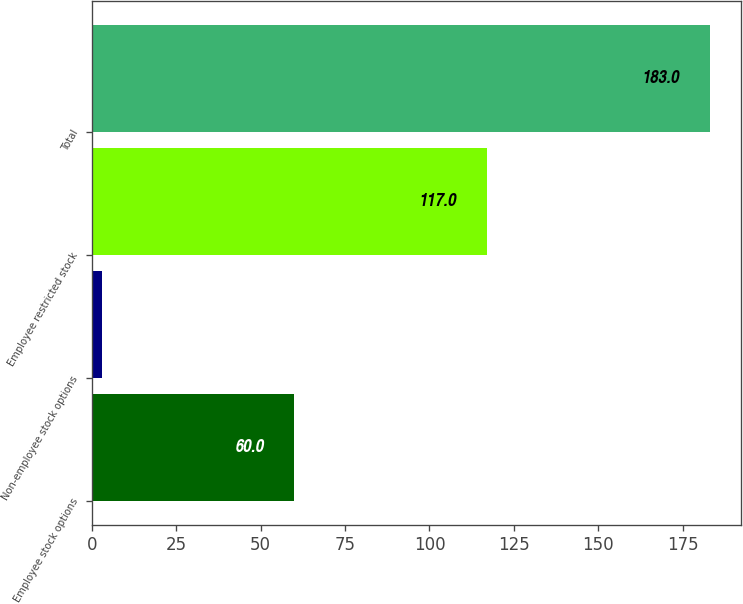Convert chart to OTSL. <chart><loc_0><loc_0><loc_500><loc_500><bar_chart><fcel>Employee stock options<fcel>Non-employee stock options<fcel>Employee restricted stock<fcel>Total<nl><fcel>60<fcel>3<fcel>117<fcel>183<nl></chart> 